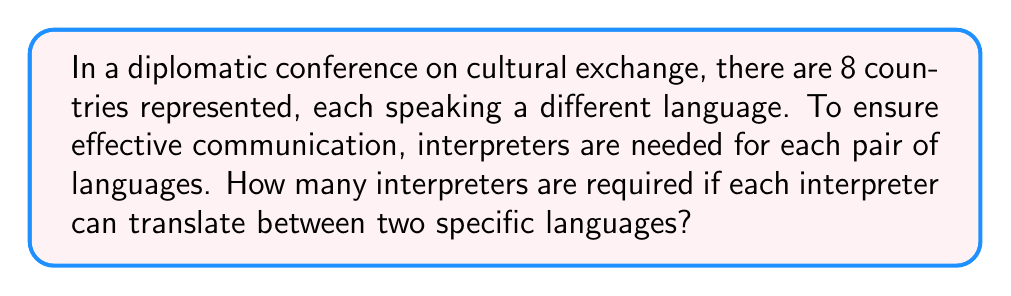Could you help me with this problem? To solve this problem, we need to follow these steps:

1) First, we need to understand that for each pair of languages, we need one interpreter. This is because an interpreter who can translate from Language A to Language B can also translate from B to A.

2) Next, we need to calculate how many unique pairs of languages we can form from 8 languages. This is a combination problem.

3) The formula for combinations is:

   $$C(n,r) = \frac{n!}{r!(n-r)!}$$

   Where $n$ is the total number of items (in this case, languages), and $r$ is the number we're choosing at a time (in this case, 2 for pairs).

4) Plugging in our values:

   $$C(8,2) = \frac{8!}{2!(8-2)!} = \frac{8!}{2!(6)!}$$

5) Expanding this:

   $$\frac{8 * 7 * 6!}{2 * 1 * 6!}$$

6) The 6! cancels out in the numerator and denominator:

   $$\frac{8 * 7}{2 * 1} = \frac{56}{2} = 28$$

Therefore, 28 interpreters are needed to cover all possible language pairs in the conference.
Answer: 28 interpreters 